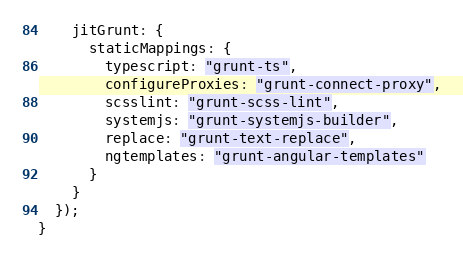<code> <loc_0><loc_0><loc_500><loc_500><_JavaScript_>    jitGrunt: {
      staticMappings: {
        typescript: "grunt-ts",
        configureProxies: "grunt-connect-proxy",
        scsslint: "grunt-scss-lint",
        systemjs: "grunt-systemjs-builder",
        replace: "grunt-text-replace",
        ngtemplates: "grunt-angular-templates"
      }
    }
  });
}
</code> 